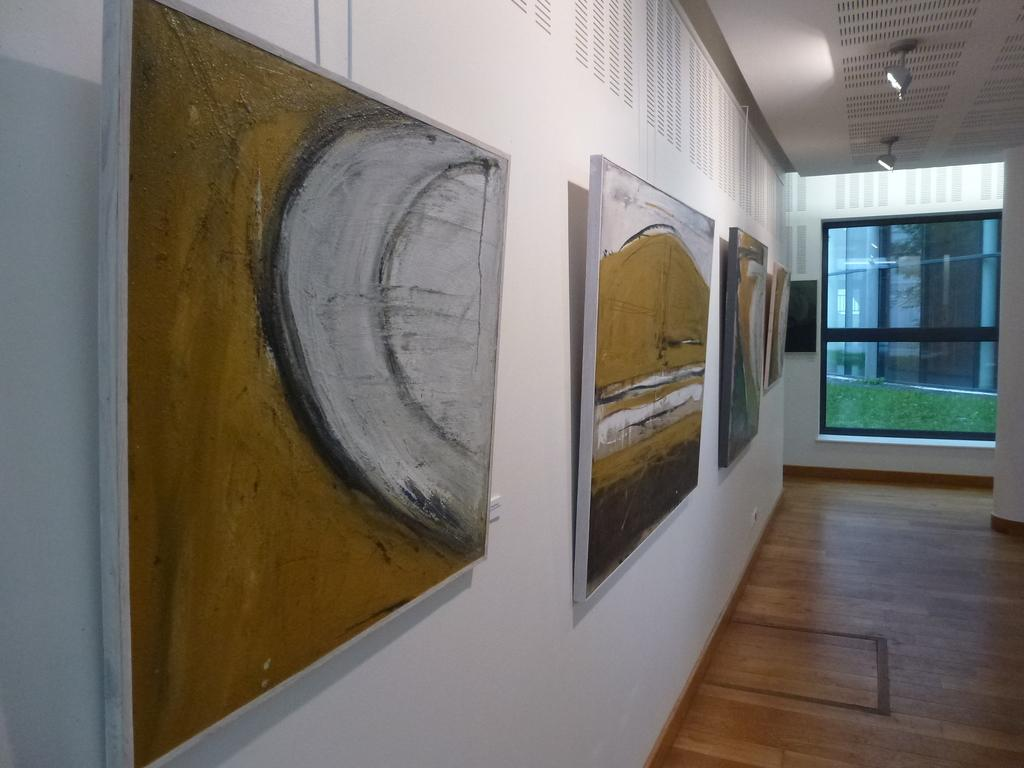What can be seen on the wall in the image? There are paintings on the wall in the image. How would you describe the appearance of the wall? The wall is plain and white. What is located on the right side of the image? There is a glass window on the right side of the image. What part of the building can be seen in the image? The floor is visible in the image. What provides shelter from the elements in the image? There is a roof at the top of the image. Where is the committee meeting taking place in the image? There is no mention of a committee or a meeting in the image; it features paintings on a wall, a glass window, a plain white wall, a visible floor, and a roof for shelter. 